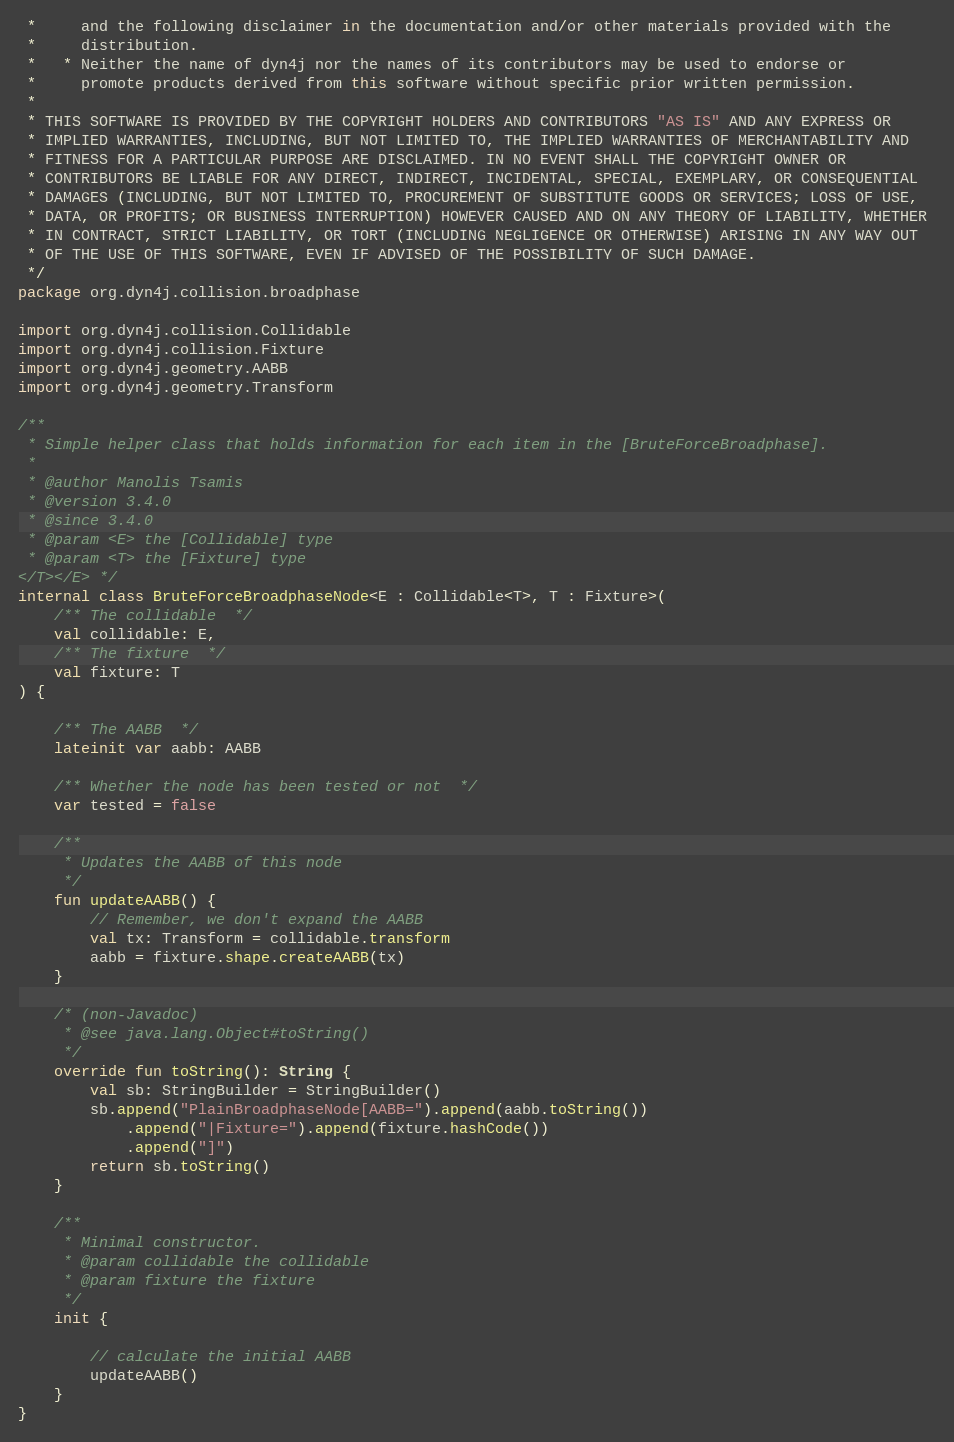<code> <loc_0><loc_0><loc_500><loc_500><_Kotlin_> *     and the following disclaimer in the documentation and/or other materials provided with the 
 *     distribution.
 *   * Neither the name of dyn4j nor the names of its contributors may be used to endorse or 
 *     promote products derived from this software without specific prior written permission.
 * 
 * THIS SOFTWARE IS PROVIDED BY THE COPYRIGHT HOLDERS AND CONTRIBUTORS "AS IS" AND ANY EXPRESS OR 
 * IMPLIED WARRANTIES, INCLUDING, BUT NOT LIMITED TO, THE IMPLIED WARRANTIES OF MERCHANTABILITY AND 
 * FITNESS FOR A PARTICULAR PURPOSE ARE DISCLAIMED. IN NO EVENT SHALL THE COPYRIGHT OWNER OR 
 * CONTRIBUTORS BE LIABLE FOR ANY DIRECT, INDIRECT, INCIDENTAL, SPECIAL, EXEMPLARY, OR CONSEQUENTIAL 
 * DAMAGES (INCLUDING, BUT NOT LIMITED TO, PROCUREMENT OF SUBSTITUTE GOODS OR SERVICES; LOSS OF USE, 
 * DATA, OR PROFITS; OR BUSINESS INTERRUPTION) HOWEVER CAUSED AND ON ANY THEORY OF LIABILITY, WHETHER 
 * IN CONTRACT, STRICT LIABILITY, OR TORT (INCLUDING NEGLIGENCE OR OTHERWISE) ARISING IN ANY WAY OUT 
 * OF THE USE OF THIS SOFTWARE, EVEN IF ADVISED OF THE POSSIBILITY OF SUCH DAMAGE.
 */
package org.dyn4j.collision.broadphase

import org.dyn4j.collision.Collidable
import org.dyn4j.collision.Fixture
import org.dyn4j.geometry.AABB
import org.dyn4j.geometry.Transform

/**
 * Simple helper class that holds information for each item in the [BruteForceBroadphase].
 *
 * @author Manolis Tsamis
 * @version 3.4.0
 * @since 3.4.0
 * @param <E> the [Collidable] type
 * @param <T> the [Fixture] type
</T></E> */
internal class BruteForceBroadphaseNode<E : Collidable<T>, T : Fixture>(
    /** The collidable  */
    val collidable: E,
    /** The fixture  */
    val fixture: T
) {

    /** The AABB  */
    lateinit var aabb: AABB

    /** Whether the node has been tested or not  */
    var tested = false

    /**
     * Updates the AABB of this node
     */
    fun updateAABB() {
        // Remember, we don't expand the AABB
        val tx: Transform = collidable.transform
        aabb = fixture.shape.createAABB(tx)
    }

    /* (non-Javadoc)
	 * @see java.lang.Object#toString()
	 */
    override fun toString(): String {
        val sb: StringBuilder = StringBuilder()
        sb.append("PlainBroadphaseNode[AABB=").append(aabb.toString())
            .append("|Fixture=").append(fixture.hashCode())
            .append("]")
        return sb.toString()
    }

    /**
     * Minimal constructor.
     * @param collidable the collidable
     * @param fixture the fixture
     */
    init {

        // calculate the initial AABB
        updateAABB()
    }
}</code> 